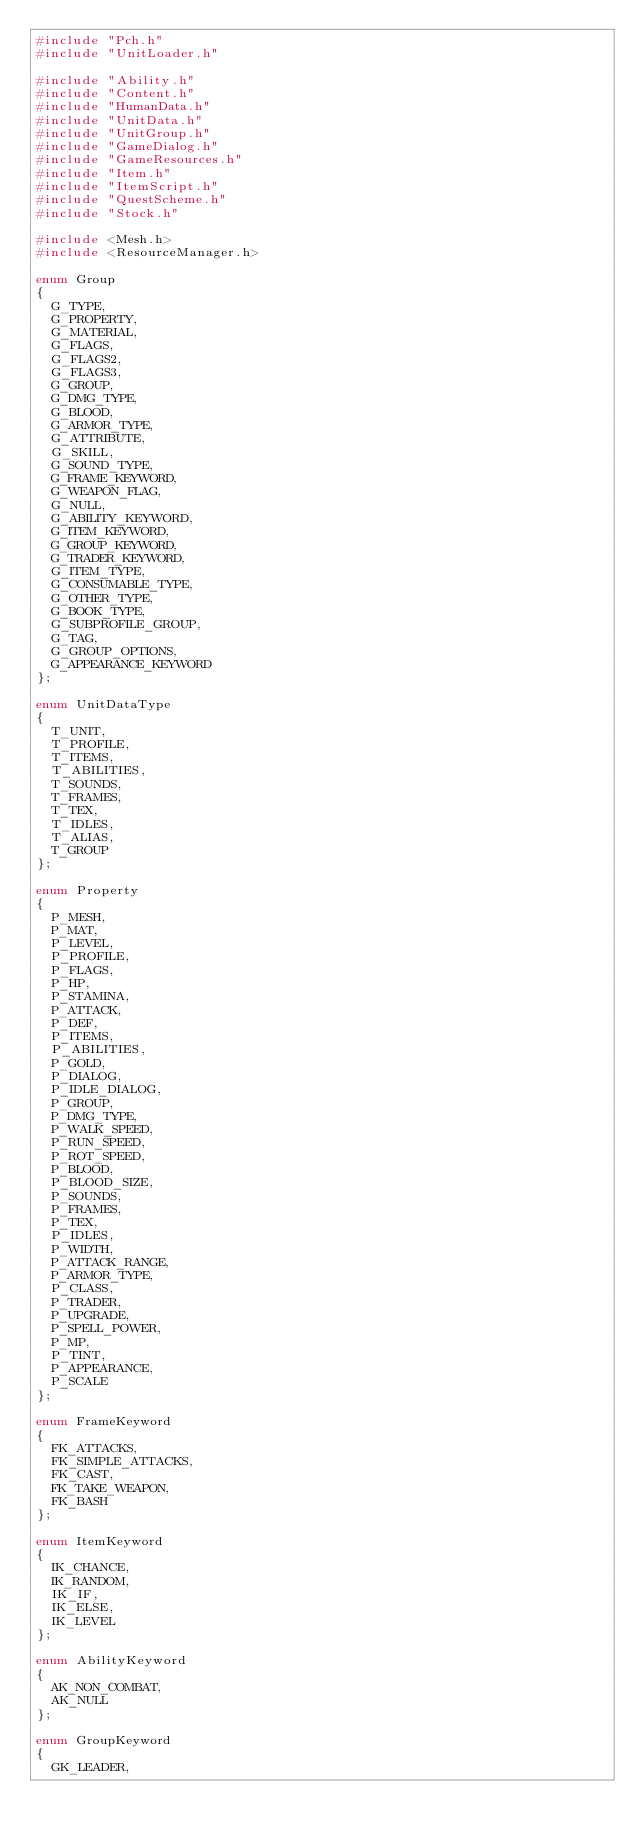<code> <loc_0><loc_0><loc_500><loc_500><_C++_>#include "Pch.h"
#include "UnitLoader.h"

#include "Ability.h"
#include "Content.h"
#include "HumanData.h"
#include "UnitData.h"
#include "UnitGroup.h"
#include "GameDialog.h"
#include "GameResources.h"
#include "Item.h"
#include "ItemScript.h"
#include "QuestScheme.h"
#include "Stock.h"

#include <Mesh.h>
#include <ResourceManager.h>

enum Group
{
	G_TYPE,
	G_PROPERTY,
	G_MATERIAL,
	G_FLAGS,
	G_FLAGS2,
	G_FLAGS3,
	G_GROUP,
	G_DMG_TYPE,
	G_BLOOD,
	G_ARMOR_TYPE,
	G_ATTRIBUTE,
	G_SKILL,
	G_SOUND_TYPE,
	G_FRAME_KEYWORD,
	G_WEAPON_FLAG,
	G_NULL,
	G_ABILITY_KEYWORD,
	G_ITEM_KEYWORD,
	G_GROUP_KEYWORD,
	G_TRADER_KEYWORD,
	G_ITEM_TYPE,
	G_CONSUMABLE_TYPE,
	G_OTHER_TYPE,
	G_BOOK_TYPE,
	G_SUBPROFILE_GROUP,
	G_TAG,
	G_GROUP_OPTIONS,
	G_APPEARANCE_KEYWORD
};

enum UnitDataType
{
	T_UNIT,
	T_PROFILE,
	T_ITEMS,
	T_ABILITIES,
	T_SOUNDS,
	T_FRAMES,
	T_TEX,
	T_IDLES,
	T_ALIAS,
	T_GROUP
};

enum Property
{
	P_MESH,
	P_MAT,
	P_LEVEL,
	P_PROFILE,
	P_FLAGS,
	P_HP,
	P_STAMINA,
	P_ATTACK,
	P_DEF,
	P_ITEMS,
	P_ABILITIES,
	P_GOLD,
	P_DIALOG,
	P_IDLE_DIALOG,
	P_GROUP,
	P_DMG_TYPE,
	P_WALK_SPEED,
	P_RUN_SPEED,
	P_ROT_SPEED,
	P_BLOOD,
	P_BLOOD_SIZE,
	P_SOUNDS,
	P_FRAMES,
	P_TEX,
	P_IDLES,
	P_WIDTH,
	P_ATTACK_RANGE,
	P_ARMOR_TYPE,
	P_CLASS,
	P_TRADER,
	P_UPGRADE,
	P_SPELL_POWER,
	P_MP,
	P_TINT,
	P_APPEARANCE,
	P_SCALE
};

enum FrameKeyword
{
	FK_ATTACKS,
	FK_SIMPLE_ATTACKS,
	FK_CAST,
	FK_TAKE_WEAPON,
	FK_BASH
};

enum ItemKeyword
{
	IK_CHANCE,
	IK_RANDOM,
	IK_IF,
	IK_ELSE,
	IK_LEVEL
};

enum AbilityKeyword
{
	AK_NON_COMBAT,
	AK_NULL
};

enum GroupKeyword
{
	GK_LEADER,</code> 